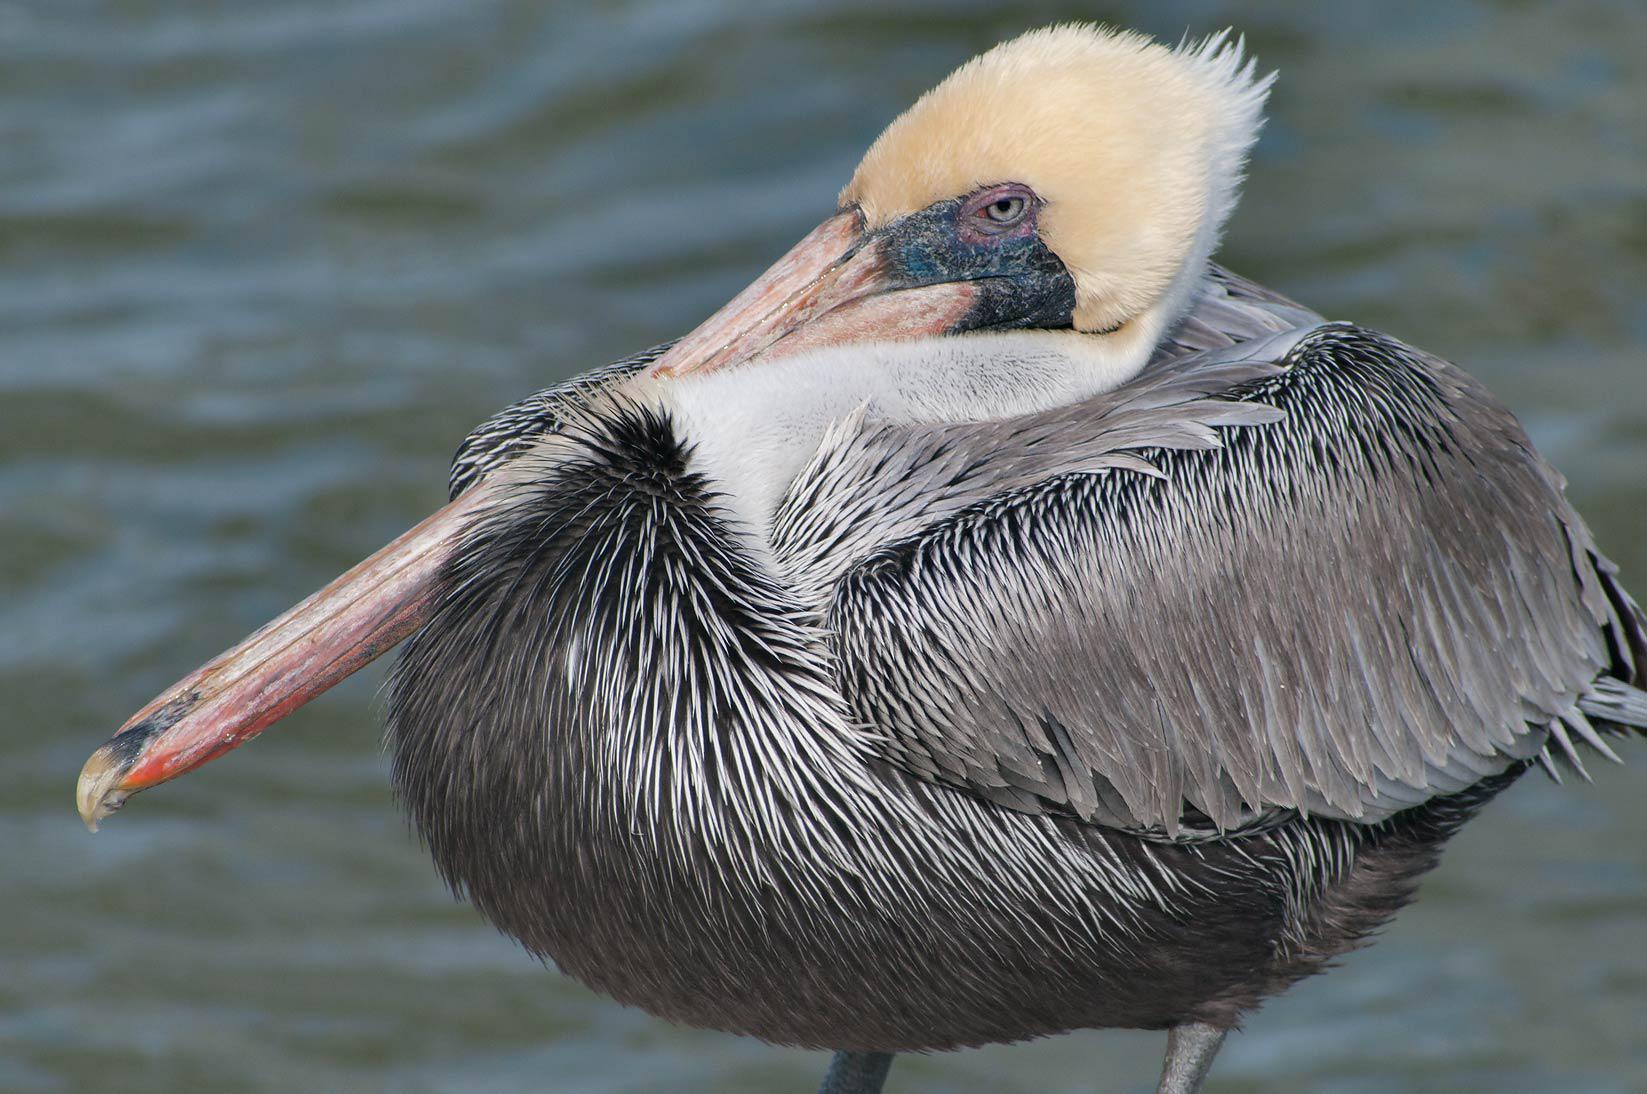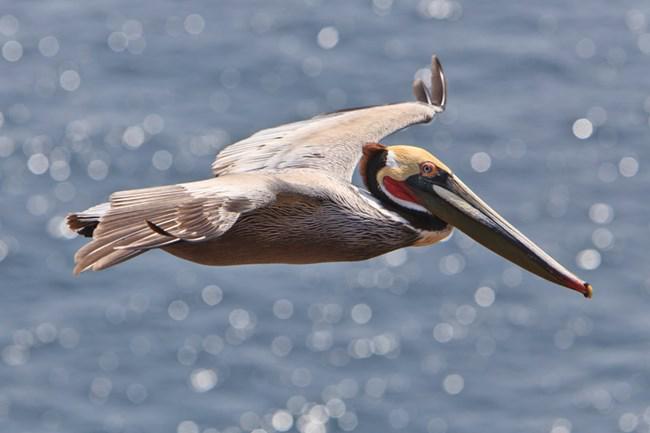The first image is the image on the left, the second image is the image on the right. For the images displayed, is the sentence "Each image shows a single pelican standing on its legs." factually correct? Answer yes or no. No. The first image is the image on the left, the second image is the image on the right. Given the left and right images, does the statement "There are only two birds that are standing." hold true? Answer yes or no. No. 